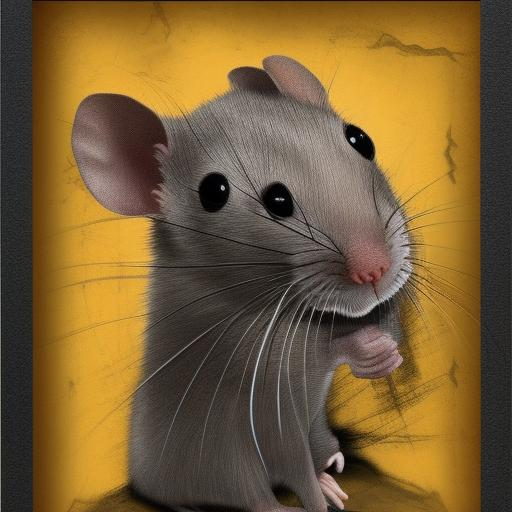How would you describe the overall clarity of the image? The overall clarity of the image is excellent. The details of the mouse's fur texture, whiskers, and the subtle shadows around its eyes are sharply defined, contributing to a vivid and crisp portrayal against the contrasting yellow background. 